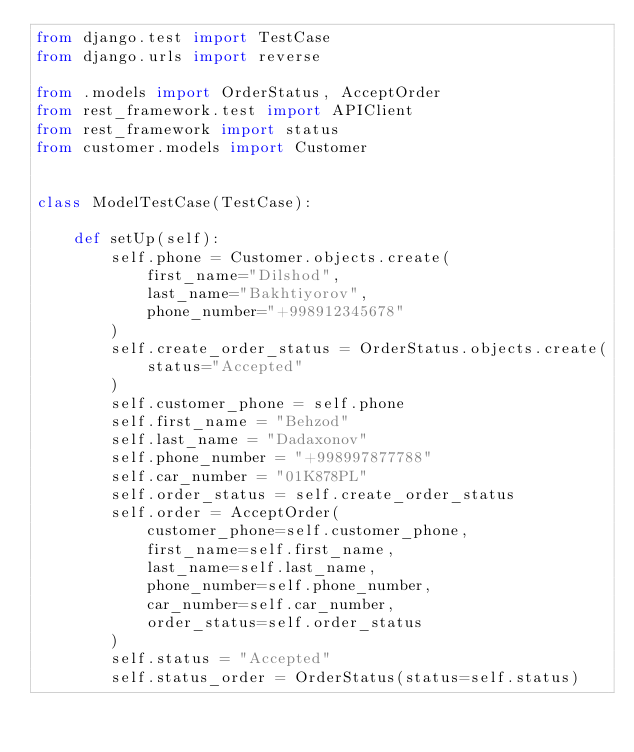Convert code to text. <code><loc_0><loc_0><loc_500><loc_500><_Python_>from django.test import TestCase
from django.urls import reverse

from .models import OrderStatus, AcceptOrder
from rest_framework.test import APIClient
from rest_framework import status
from customer.models import Customer


class ModelTestCase(TestCase):

    def setUp(self):
        self.phone = Customer.objects.create(
            first_name="Dilshod",
            last_name="Bakhtiyorov",
            phone_number="+998912345678"
        )
        self.create_order_status = OrderStatus.objects.create(
            status="Accepted"
        )
        self.customer_phone = self.phone
        self.first_name = "Behzod"
        self.last_name = "Dadaxonov"
        self.phone_number = "+998997877788"
        self.car_number = "01K878PL"
        self.order_status = self.create_order_status
        self.order = AcceptOrder(
            customer_phone=self.customer_phone,
            first_name=self.first_name,
            last_name=self.last_name,
            phone_number=self.phone_number,
            car_number=self.car_number,
            order_status=self.order_status
        )
        self.status = "Accepted"
        self.status_order = OrderStatus(status=self.status)
</code> 